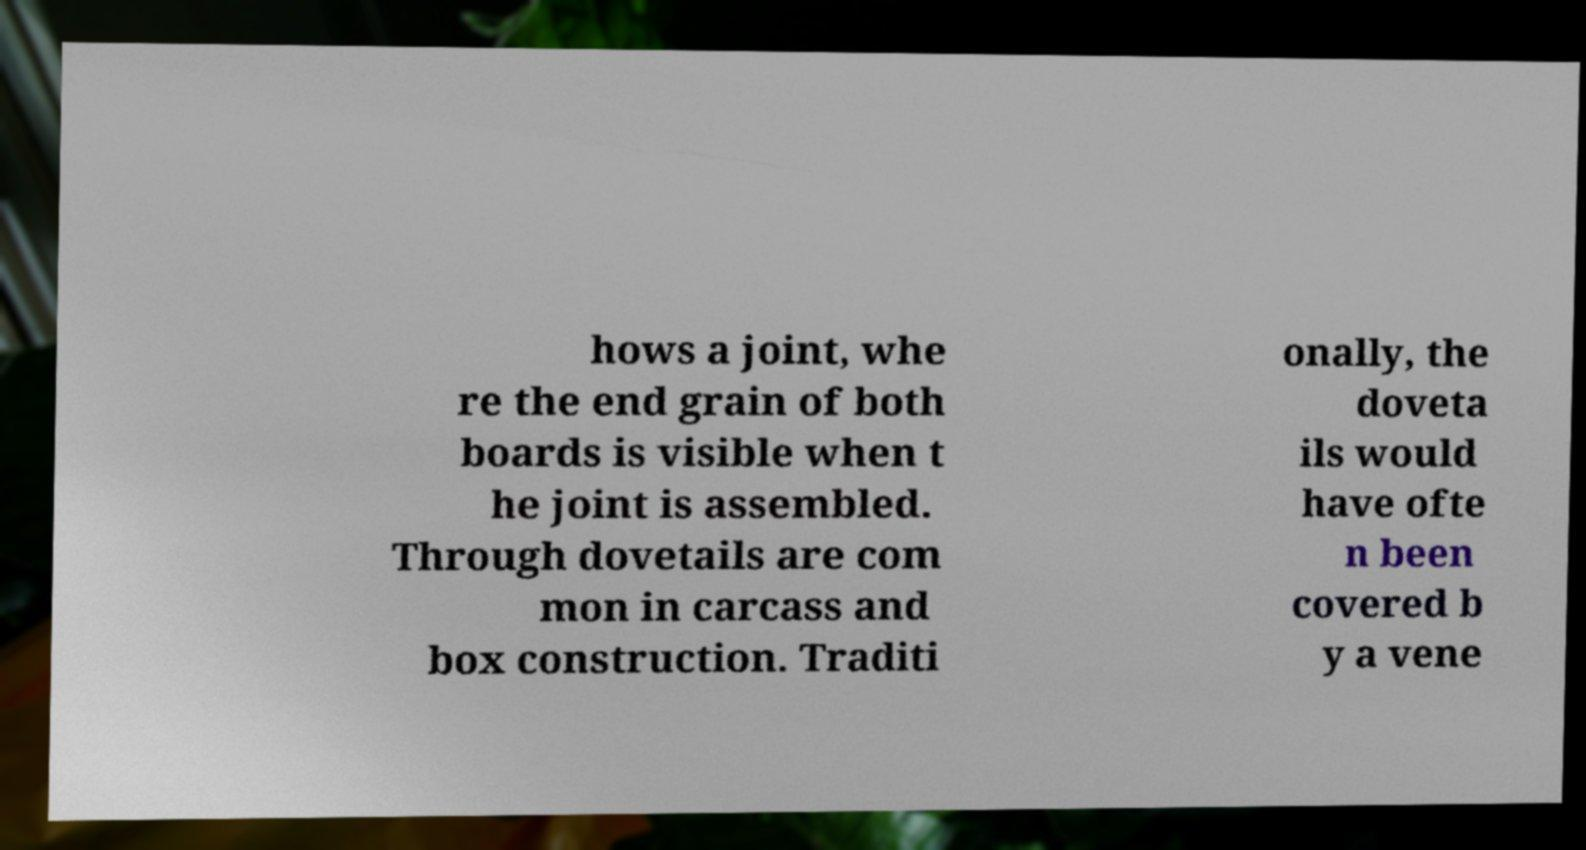Could you assist in decoding the text presented in this image and type it out clearly? hows a joint, whe re the end grain of both boards is visible when t he joint is assembled. Through dovetails are com mon in carcass and box construction. Traditi onally, the doveta ils would have ofte n been covered b y a vene 